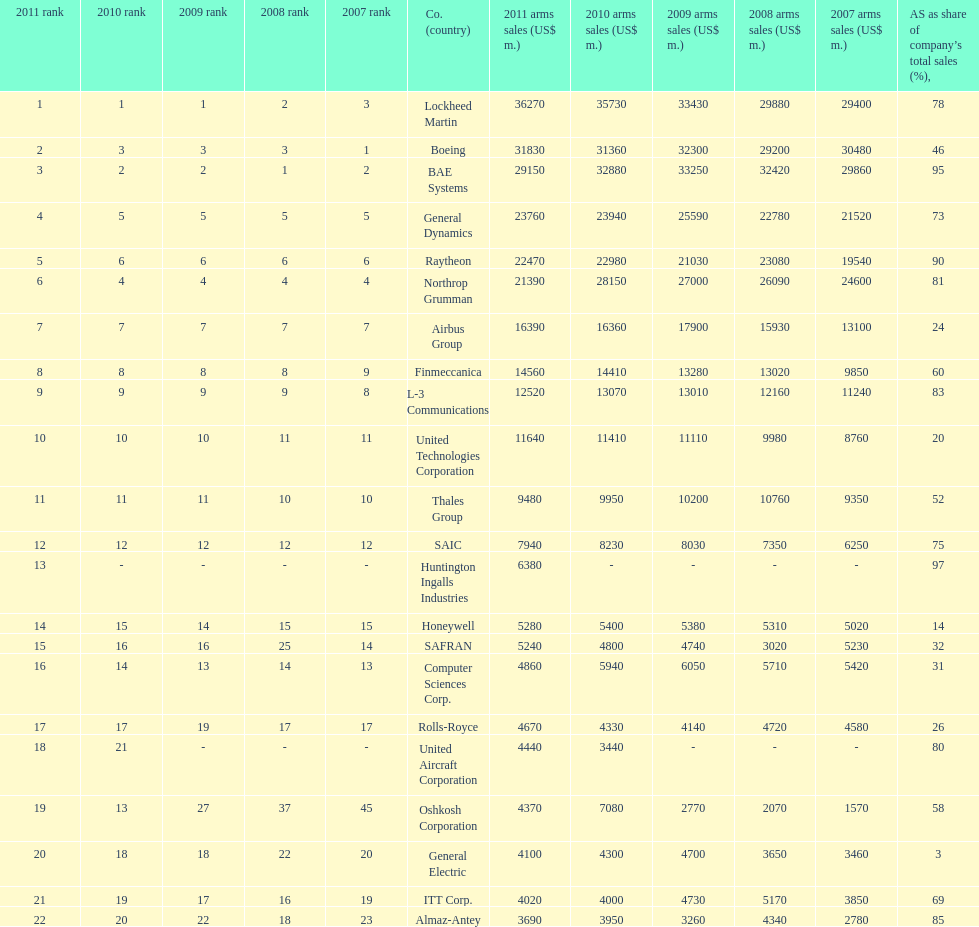How many different countries are listed? 6. 